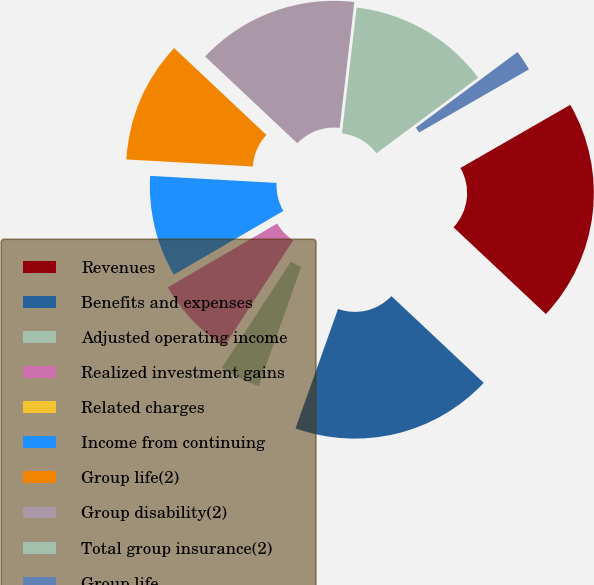Convert chart to OTSL. <chart><loc_0><loc_0><loc_500><loc_500><pie_chart><fcel>Revenues<fcel>Benefits and expenses<fcel>Adjusted operating income<fcel>Realized investment gains<fcel>Related charges<fcel>Income from continuing<fcel>Group life(2)<fcel>Group disability(2)<fcel>Total group insurance(2)<fcel>Group life<nl><fcel>20.31%<fcel>18.45%<fcel>3.72%<fcel>7.42%<fcel>0.02%<fcel>9.28%<fcel>11.13%<fcel>14.83%<fcel>12.98%<fcel>1.87%<nl></chart> 